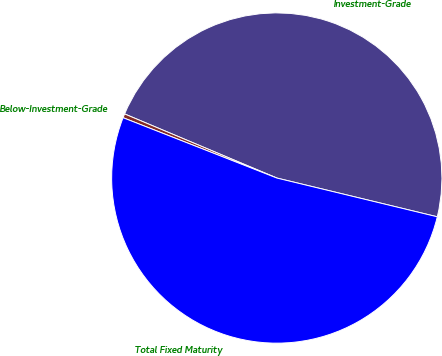<chart> <loc_0><loc_0><loc_500><loc_500><pie_chart><fcel>Investment-Grade<fcel>Below-Investment-Grade<fcel>Total Fixed Maturity<nl><fcel>47.43%<fcel>0.39%<fcel>52.18%<nl></chart> 